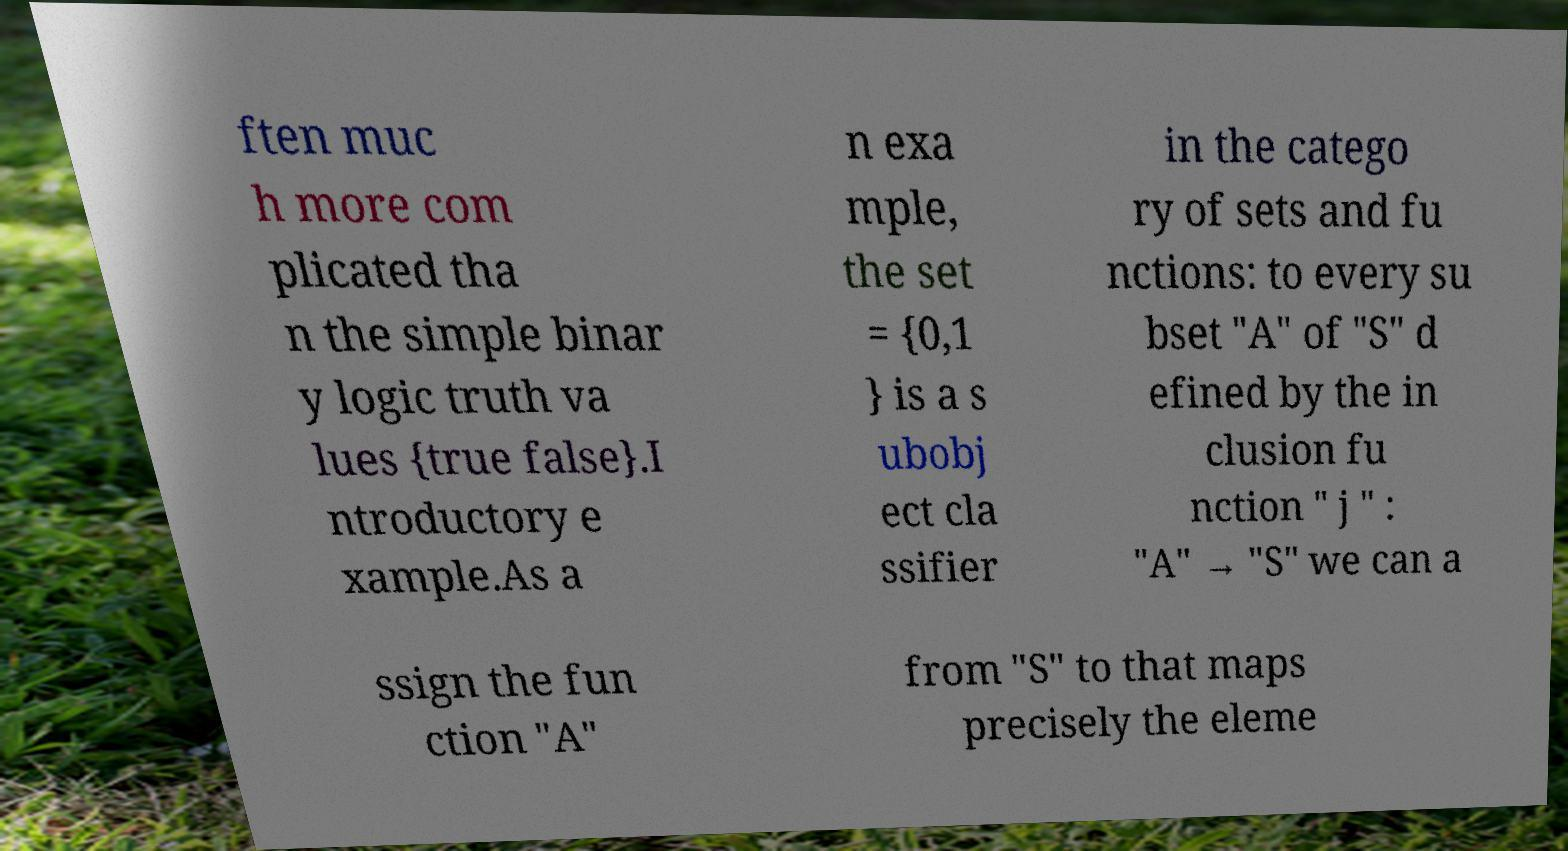For documentation purposes, I need the text within this image transcribed. Could you provide that? ften muc h more com plicated tha n the simple binar y logic truth va lues {true false}.I ntroductory e xample.As a n exa mple, the set = {0,1 } is a s ubobj ect cla ssifier in the catego ry of sets and fu nctions: to every su bset "A" of "S" d efined by the in clusion fu nction " j " : "A" → "S" we can a ssign the fun ction "A" from "S" to that maps precisely the eleme 